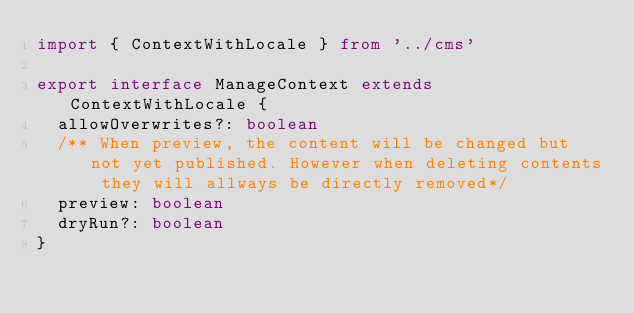<code> <loc_0><loc_0><loc_500><loc_500><_TypeScript_>import { ContextWithLocale } from '../cms'

export interface ManageContext extends ContextWithLocale {
  allowOverwrites?: boolean
  /** When preview, the content will be changed but not yet published. However when deleting contents they will allways be directly removed*/
  preview: boolean
  dryRun?: boolean
}
</code> 